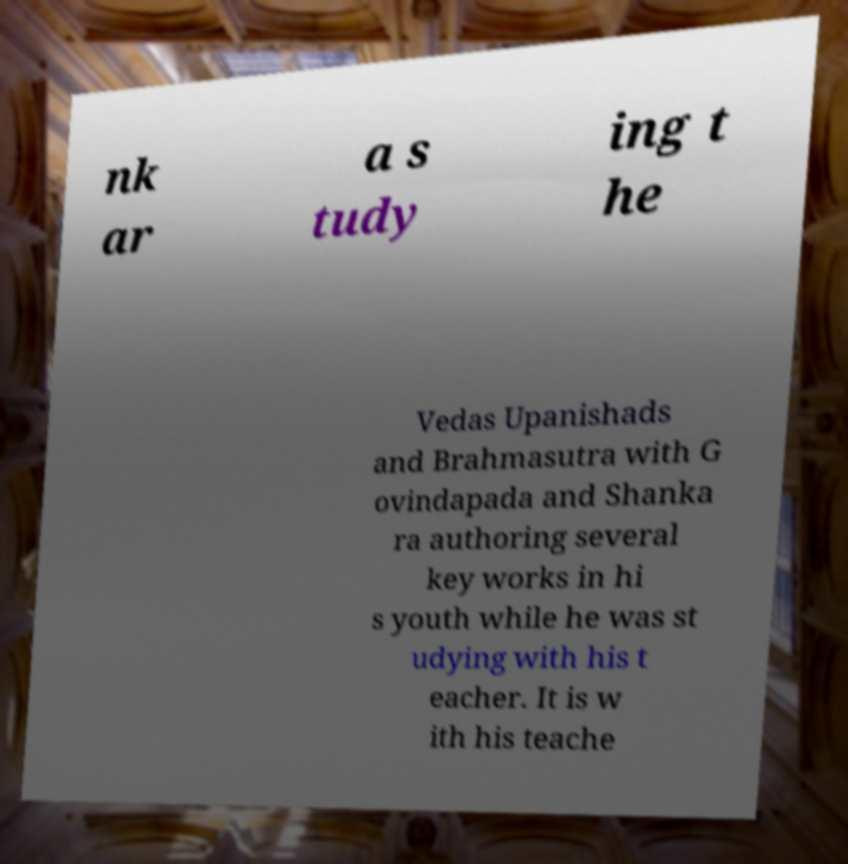What messages or text are displayed in this image? I need them in a readable, typed format. nk ar a s tudy ing t he Vedas Upanishads and Brahmasutra with G ovindapada and Shanka ra authoring several key works in hi s youth while he was st udying with his t eacher. It is w ith his teache 